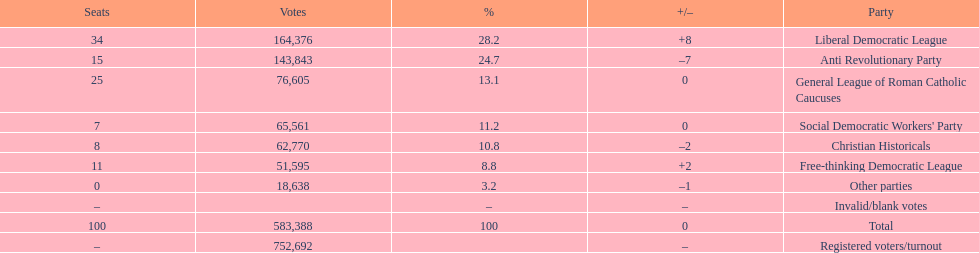How many more votes did the liberal democratic league win over the free-thinking democratic league? 112,781. 